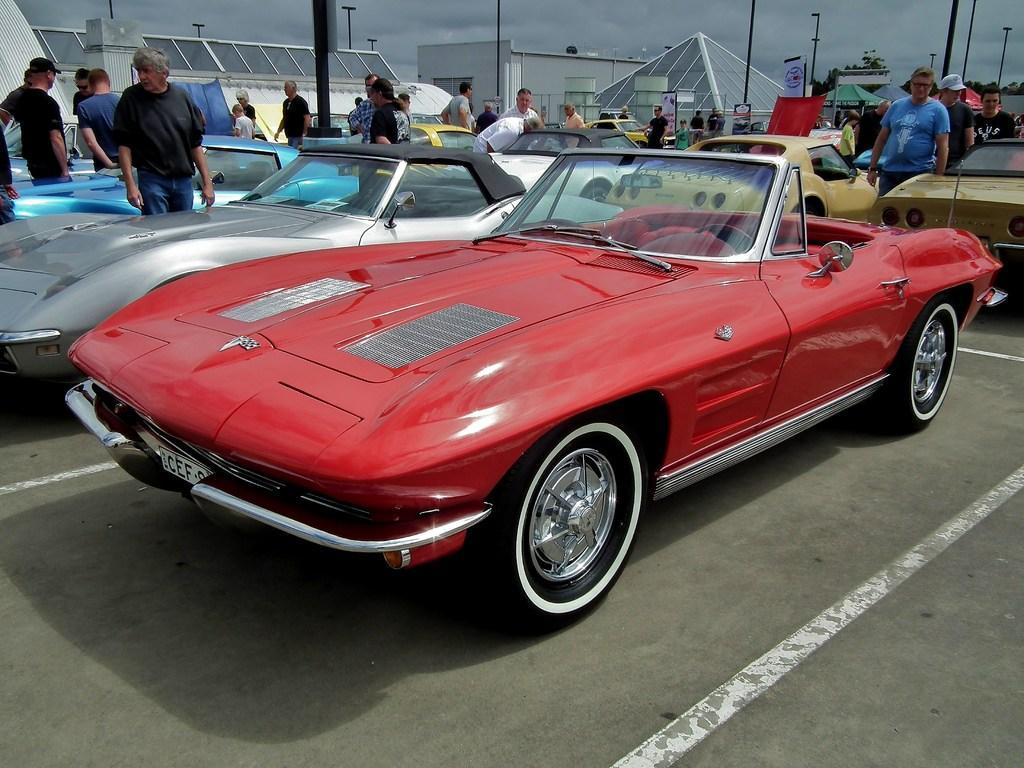Can you describe this image briefly? In this image we can see motor vehicles in the parking slots, persons standing on the floor, street poles, street lights, sheds, buildings, trees and sky with clouds. 